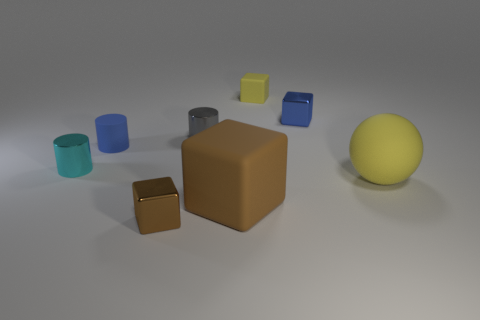There is a large matte cube; is it the same color as the tiny matte thing that is on the left side of the small brown metallic object?
Offer a very short reply. No. What number of objects are either small blocks that are behind the small cyan metal cylinder or metal cubes that are in front of the tiny blue block?
Provide a succinct answer. 3. There is a cyan cylinder that is the same size as the gray metal cylinder; what is it made of?
Give a very brief answer. Metal. How many other things are the same material as the cyan object?
Ensure brevity in your answer.  3. Do the small blue thing that is on the left side of the large brown block and the brown object right of the small gray metal cylinder have the same shape?
Make the answer very short. No. The metallic block that is on the left side of the tiny metallic cube that is behind the small shiny cylinder right of the cyan metallic cylinder is what color?
Offer a very short reply. Brown. What number of other things are the same color as the matte sphere?
Give a very brief answer. 1. Is the number of big things less than the number of red metallic cubes?
Offer a very short reply. No. There is a thing that is right of the yellow cube and in front of the blue cube; what is its color?
Your answer should be very brief. Yellow. There is a small cyan object that is the same shape as the gray metallic object; what is it made of?
Ensure brevity in your answer.  Metal. 